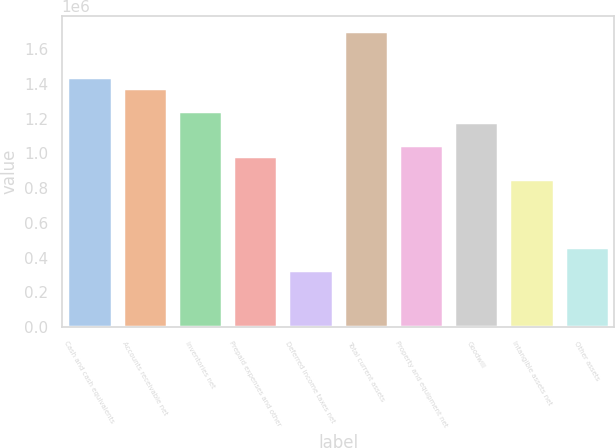Convert chart to OTSL. <chart><loc_0><loc_0><loc_500><loc_500><bar_chart><fcel>Cash and cash equivalents<fcel>Accounts receivable net<fcel>Inventories net<fcel>Prepaid expenses and other<fcel>Deferred income taxes net<fcel>Total current assets<fcel>Property and equipment net<fcel>Goodwill<fcel>Intangible assets net<fcel>Other assets<nl><fcel>1.44211e+06<fcel>1.37656e+06<fcel>1.24546e+06<fcel>983257<fcel>327757<fcel>1.70431e+06<fcel>1.04881e+06<fcel>1.17991e+06<fcel>852157<fcel>458857<nl></chart> 